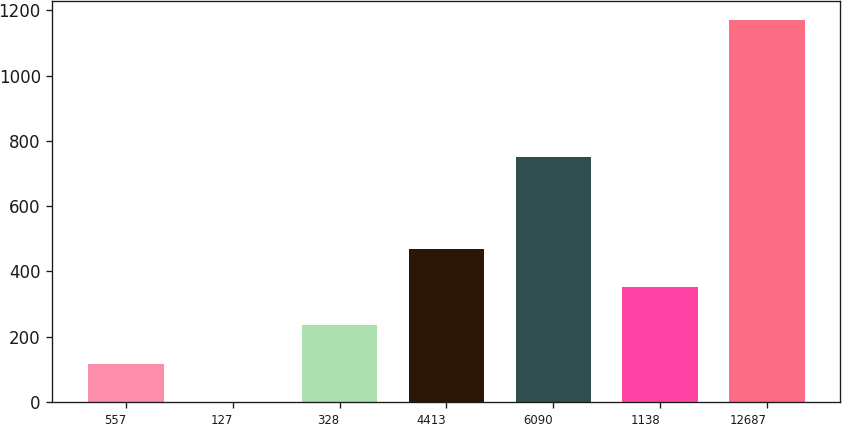Convert chart to OTSL. <chart><loc_0><loc_0><loc_500><loc_500><bar_chart><fcel>557<fcel>127<fcel>328<fcel>4413<fcel>6090<fcel>1138<fcel>12687<nl><fcel>117.34<fcel>0.3<fcel>234.38<fcel>468.46<fcel>750.6<fcel>351.42<fcel>1170.7<nl></chart> 